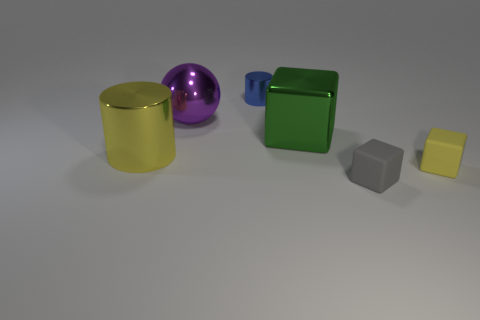Can you estimate the sizes of these objects? While an exact measurement cannot be provided without a reference scale, the objects present might be proportionate to common household items. For example, the cylinders could be the size of standard cans, the cubes might be similar in size to dice or children's blocks, and the small yellow block appears to be comparable in size to a thick coaster. 